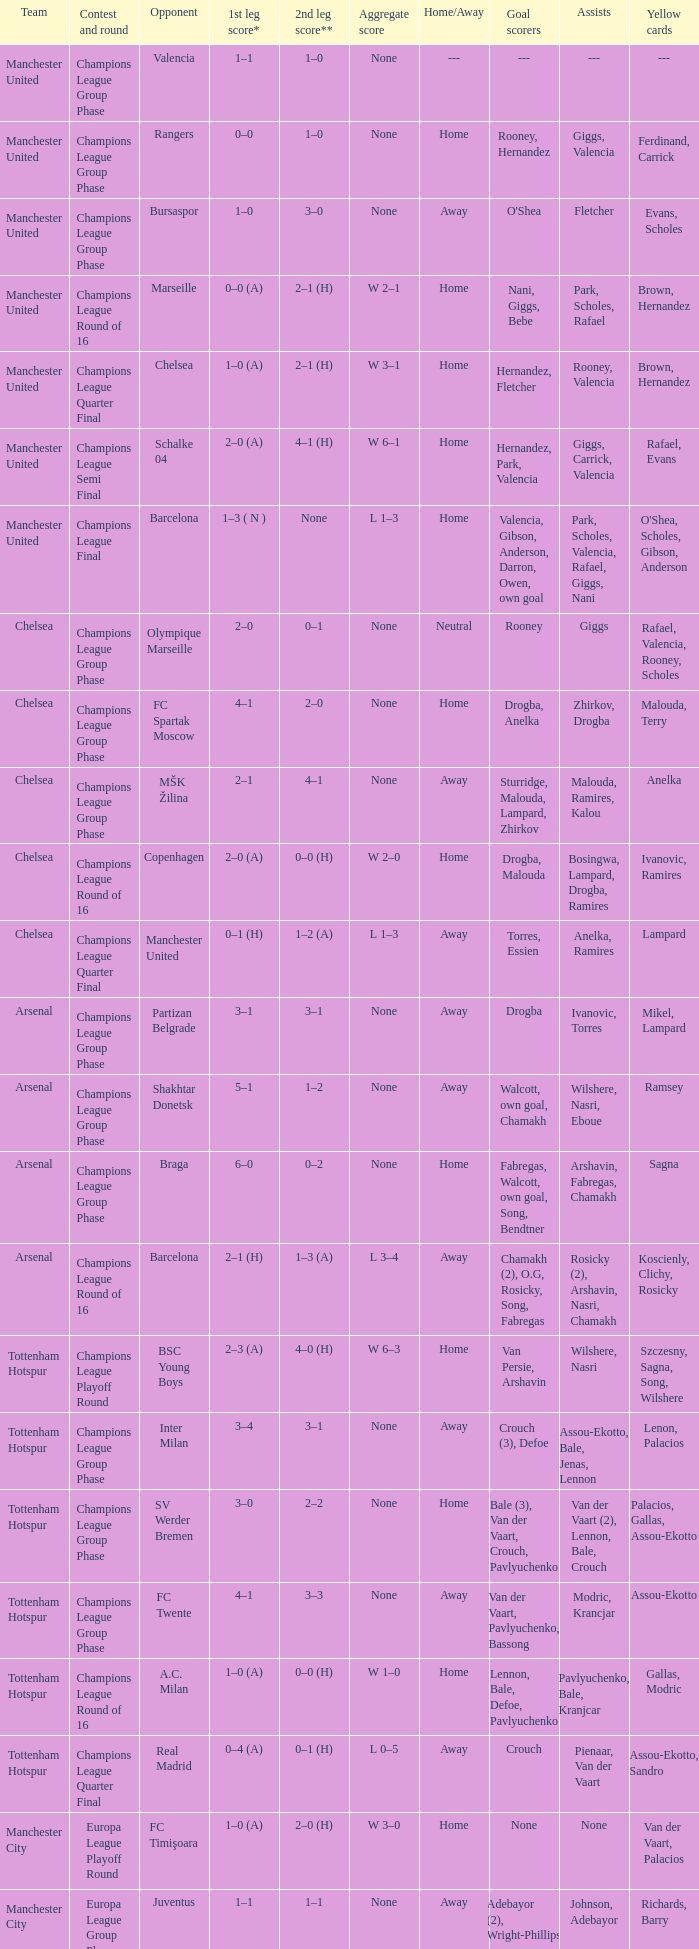What was the score between Marseille and Manchester United on the second leg of the Champions League Round of 16? 2–1 (H). 